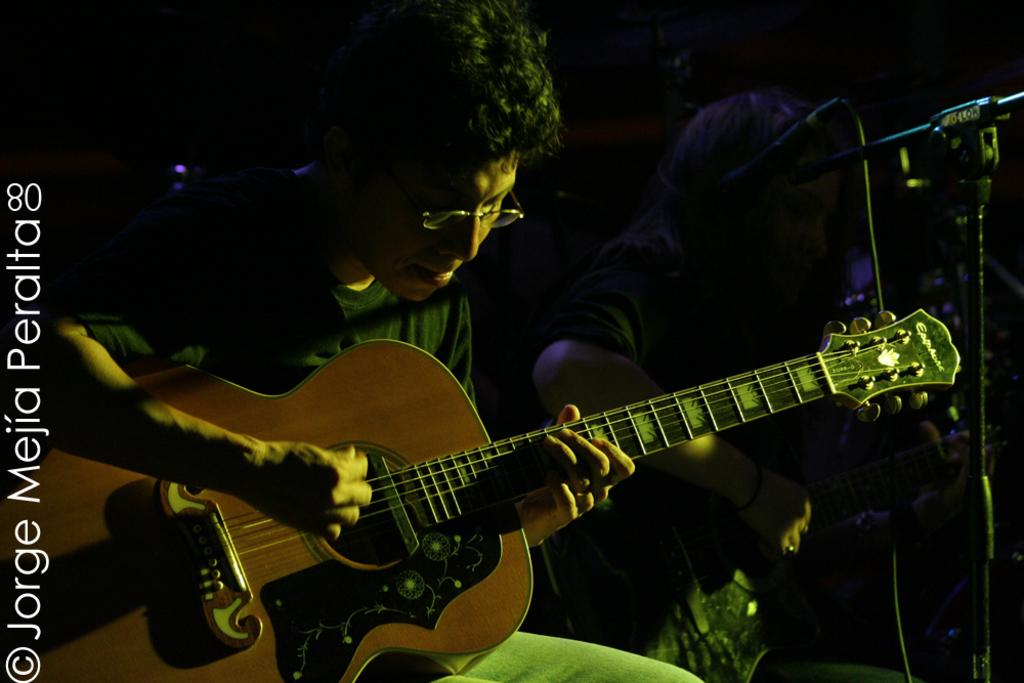What is the man in the image doing? The man is playing the guitar in the image. What can be seen on the man's face? The man is wearing spectacles in the image. What type of clothing is the man wearing? The man is wearing a T-shirt in the image. Is there anyone else in the image besides the man? Yes, there is another person beside the man in the image. What type of brain is the man using to play the guitar in the image? The man is not using a brain to play the guitar in the image; he is using his hands and fingers. 